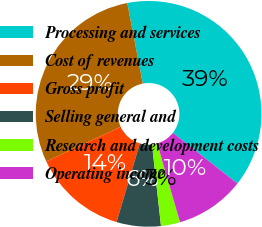Convert chart. <chart><loc_0><loc_0><loc_500><loc_500><pie_chart><fcel>Processing and services<fcel>Cost of revenues<fcel>Gross profit<fcel>Selling general and<fcel>Research and development costs<fcel>Operating income<nl><fcel>38.62%<fcel>28.89%<fcel>13.5%<fcel>6.33%<fcel>2.74%<fcel>9.92%<nl></chart> 